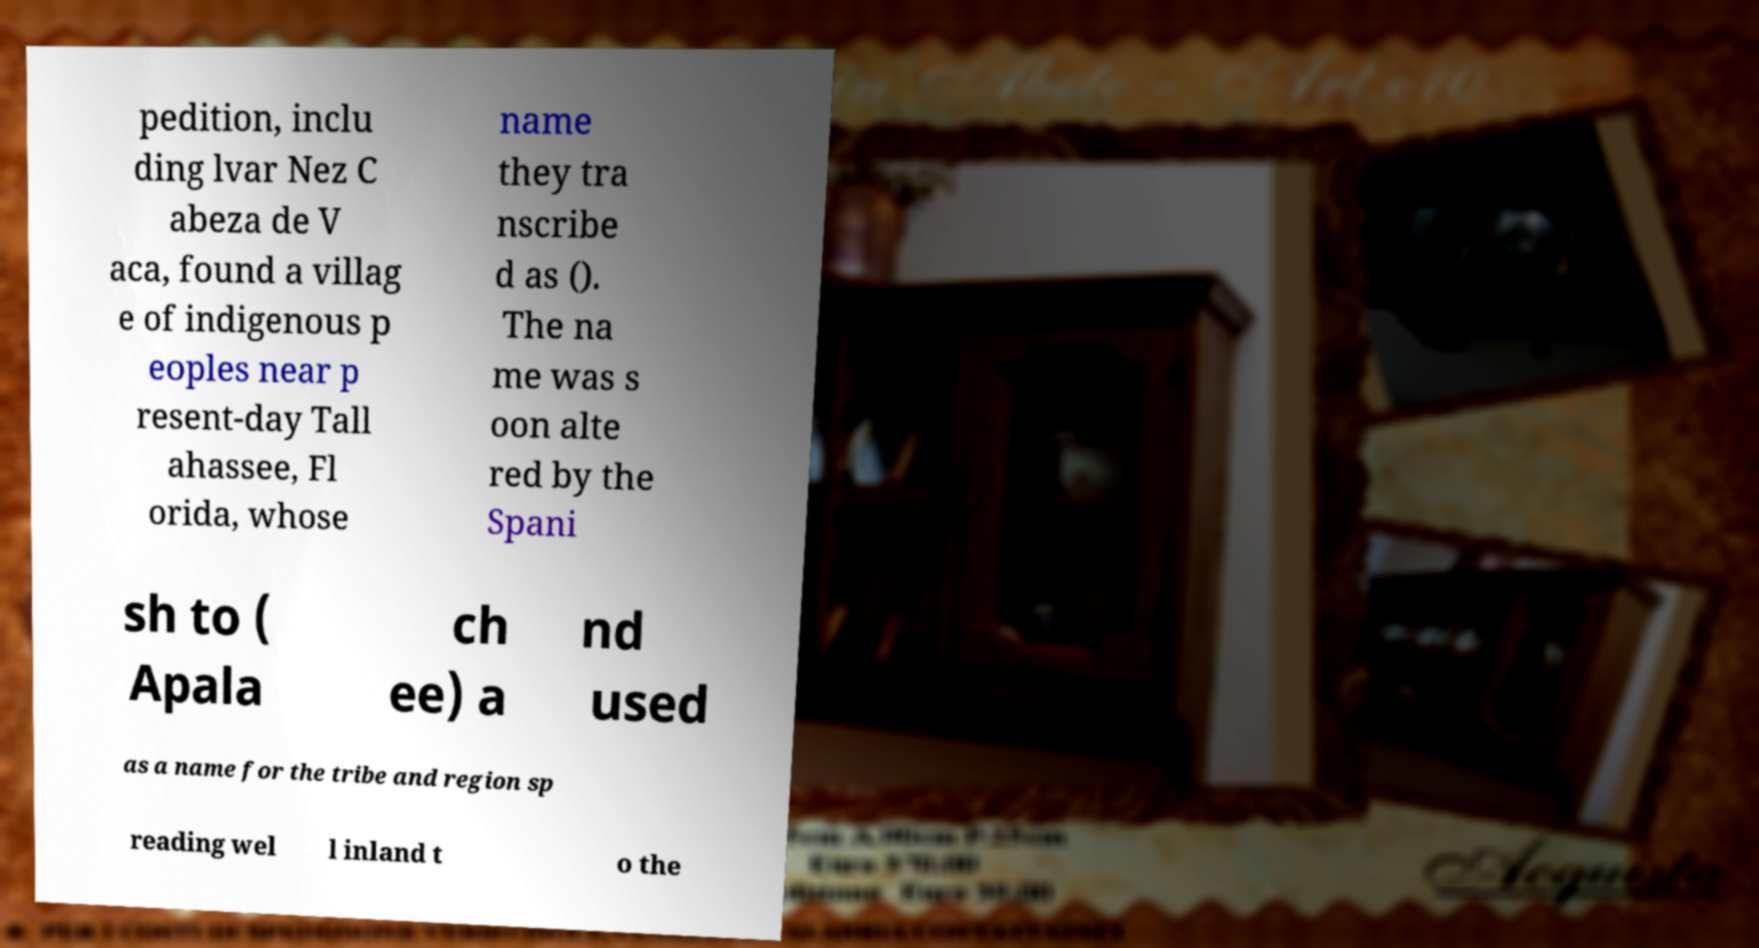What messages or text are displayed in this image? I need them in a readable, typed format. pedition, inclu ding lvar Nez C abeza de V aca, found a villag e of indigenous p eoples near p resent-day Tall ahassee, Fl orida, whose name they tra nscribe d as (). The na me was s oon alte red by the Spani sh to ( Apala ch ee) a nd used as a name for the tribe and region sp reading wel l inland t o the 